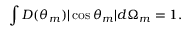Convert formula to latex. <formula><loc_0><loc_0><loc_500><loc_500>\int D ( \theta _ { m } ) | \cos \theta _ { m } | d \Omega _ { m } = 1 .</formula> 